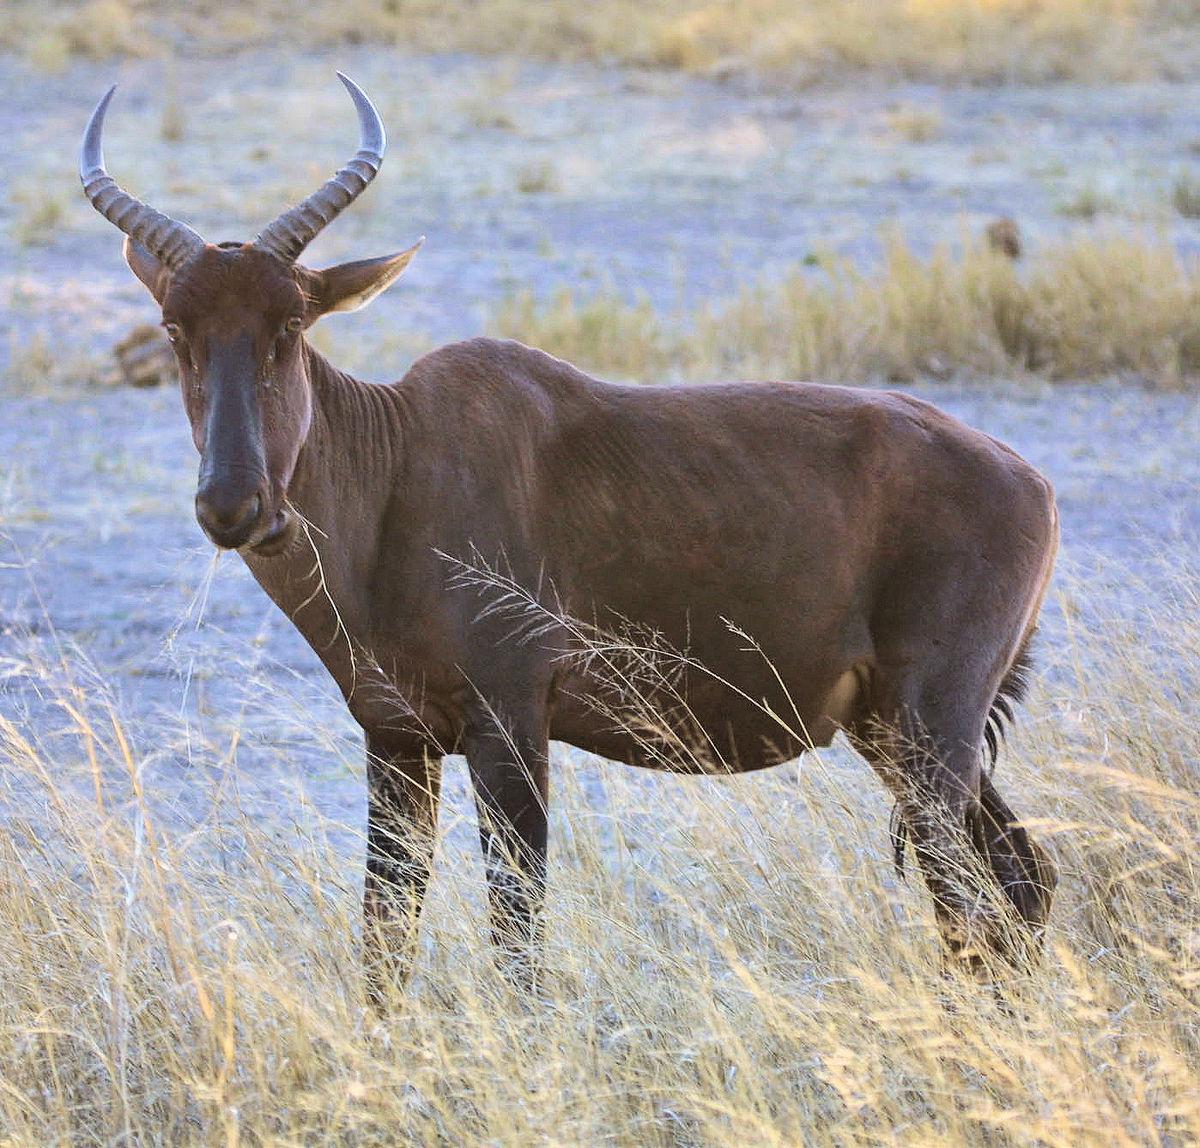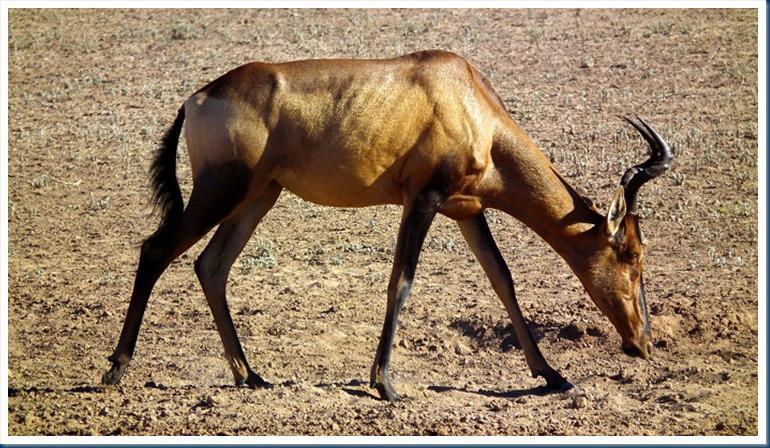The first image is the image on the left, the second image is the image on the right. Given the left and right images, does the statement "A young hooved animal without big horns stands facing right, in front of at least one big-horned animal." hold true? Answer yes or no. No. The first image is the image on the left, the second image is the image on the right. Considering the images on both sides, is "There is no more than one antelope in the right image facing right." valid? Answer yes or no. Yes. 